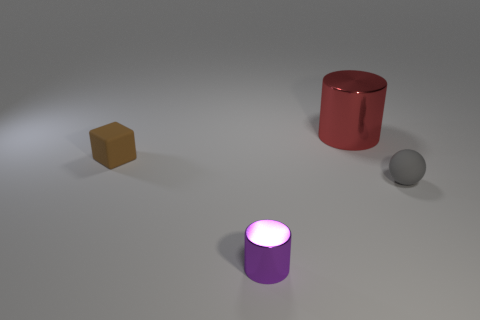Add 3 gray things. How many objects exist? 7 Subtract all spheres. How many objects are left? 3 Add 2 brown objects. How many brown objects exist? 3 Subtract 0 purple balls. How many objects are left? 4 Subtract all blue metal things. Subtract all small gray objects. How many objects are left? 3 Add 2 purple metallic objects. How many purple metallic objects are left? 3 